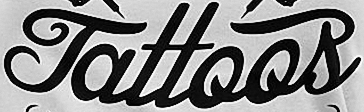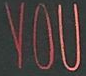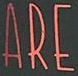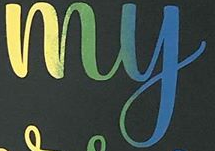Transcribe the words shown in these images in order, separated by a semicolon. Tattoos; YOU; ARE; my 